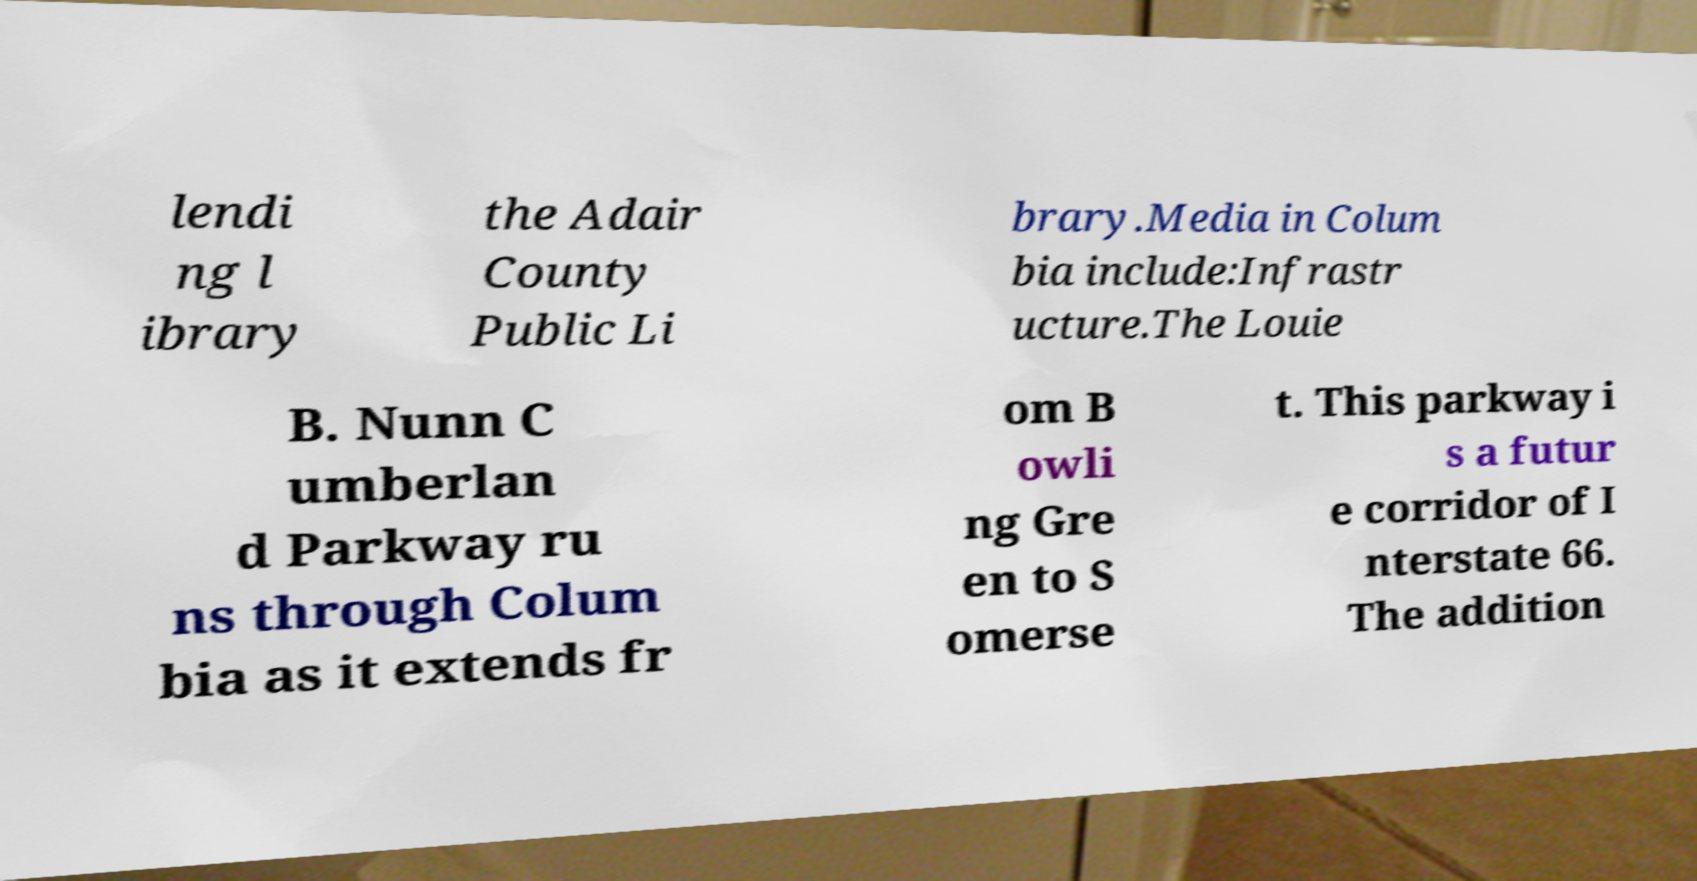Please read and relay the text visible in this image. What does it say? lendi ng l ibrary the Adair County Public Li brary.Media in Colum bia include:Infrastr ucture.The Louie B. Nunn C umberlan d Parkway ru ns through Colum bia as it extends fr om B owli ng Gre en to S omerse t. This parkway i s a futur e corridor of I nterstate 66. The addition 